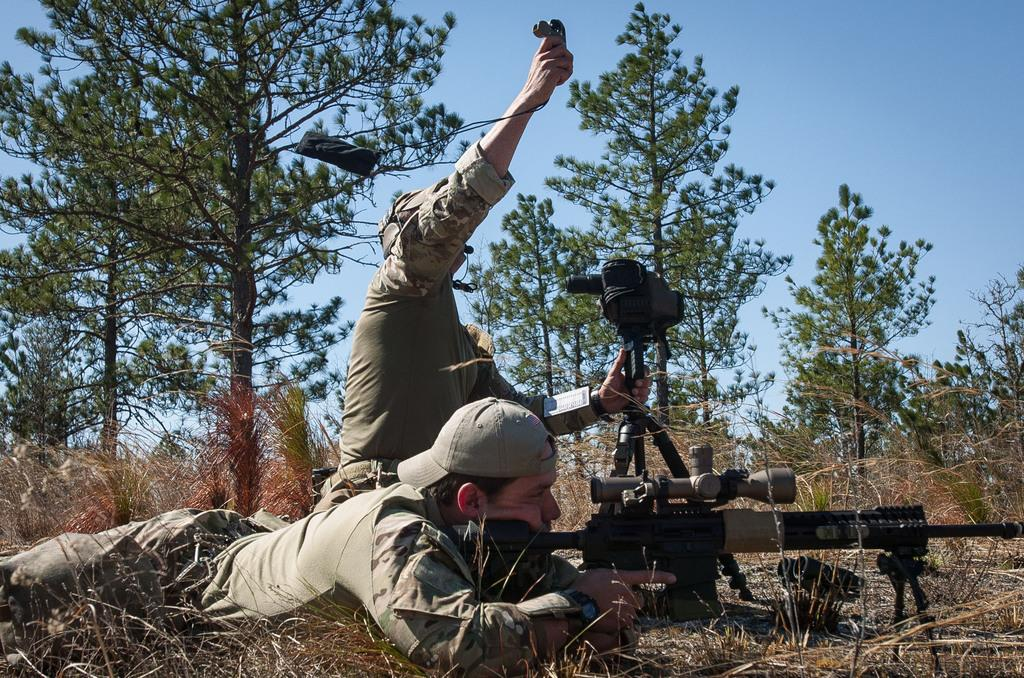What is the person in the image holding? The person in the image is holding a weapon. What are the objects being held by the other person in the image? The other person in the image is holding objects. What type of natural environment can be seen in the background of the image? There is grass, trees, and the sky visible in the background of the image. How many eggs are visible on the sidewalk in the image? There is no sidewalk or eggs present in the image. What type of creature is using the weapon in the image? There is no creature visible in the image; only the person holding the weapon can be seen. 